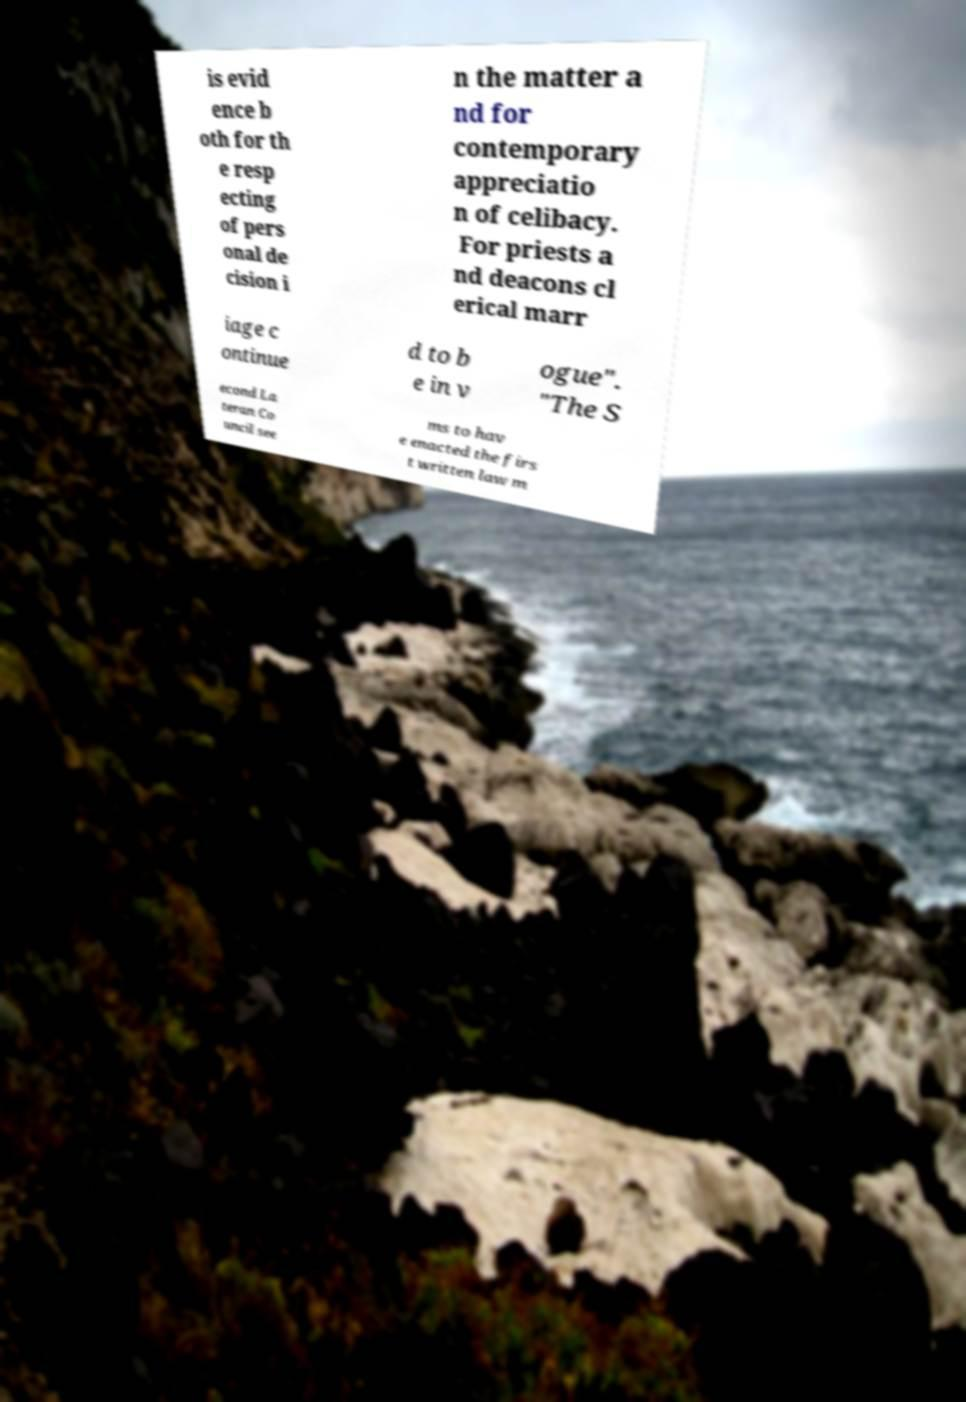Please read and relay the text visible in this image. What does it say? is evid ence b oth for th e resp ecting of pers onal de cision i n the matter a nd for contemporary appreciatio n of celibacy. For priests a nd deacons cl erical marr iage c ontinue d to b e in v ogue". "The S econd La teran Co uncil see ms to hav e enacted the firs t written law m 